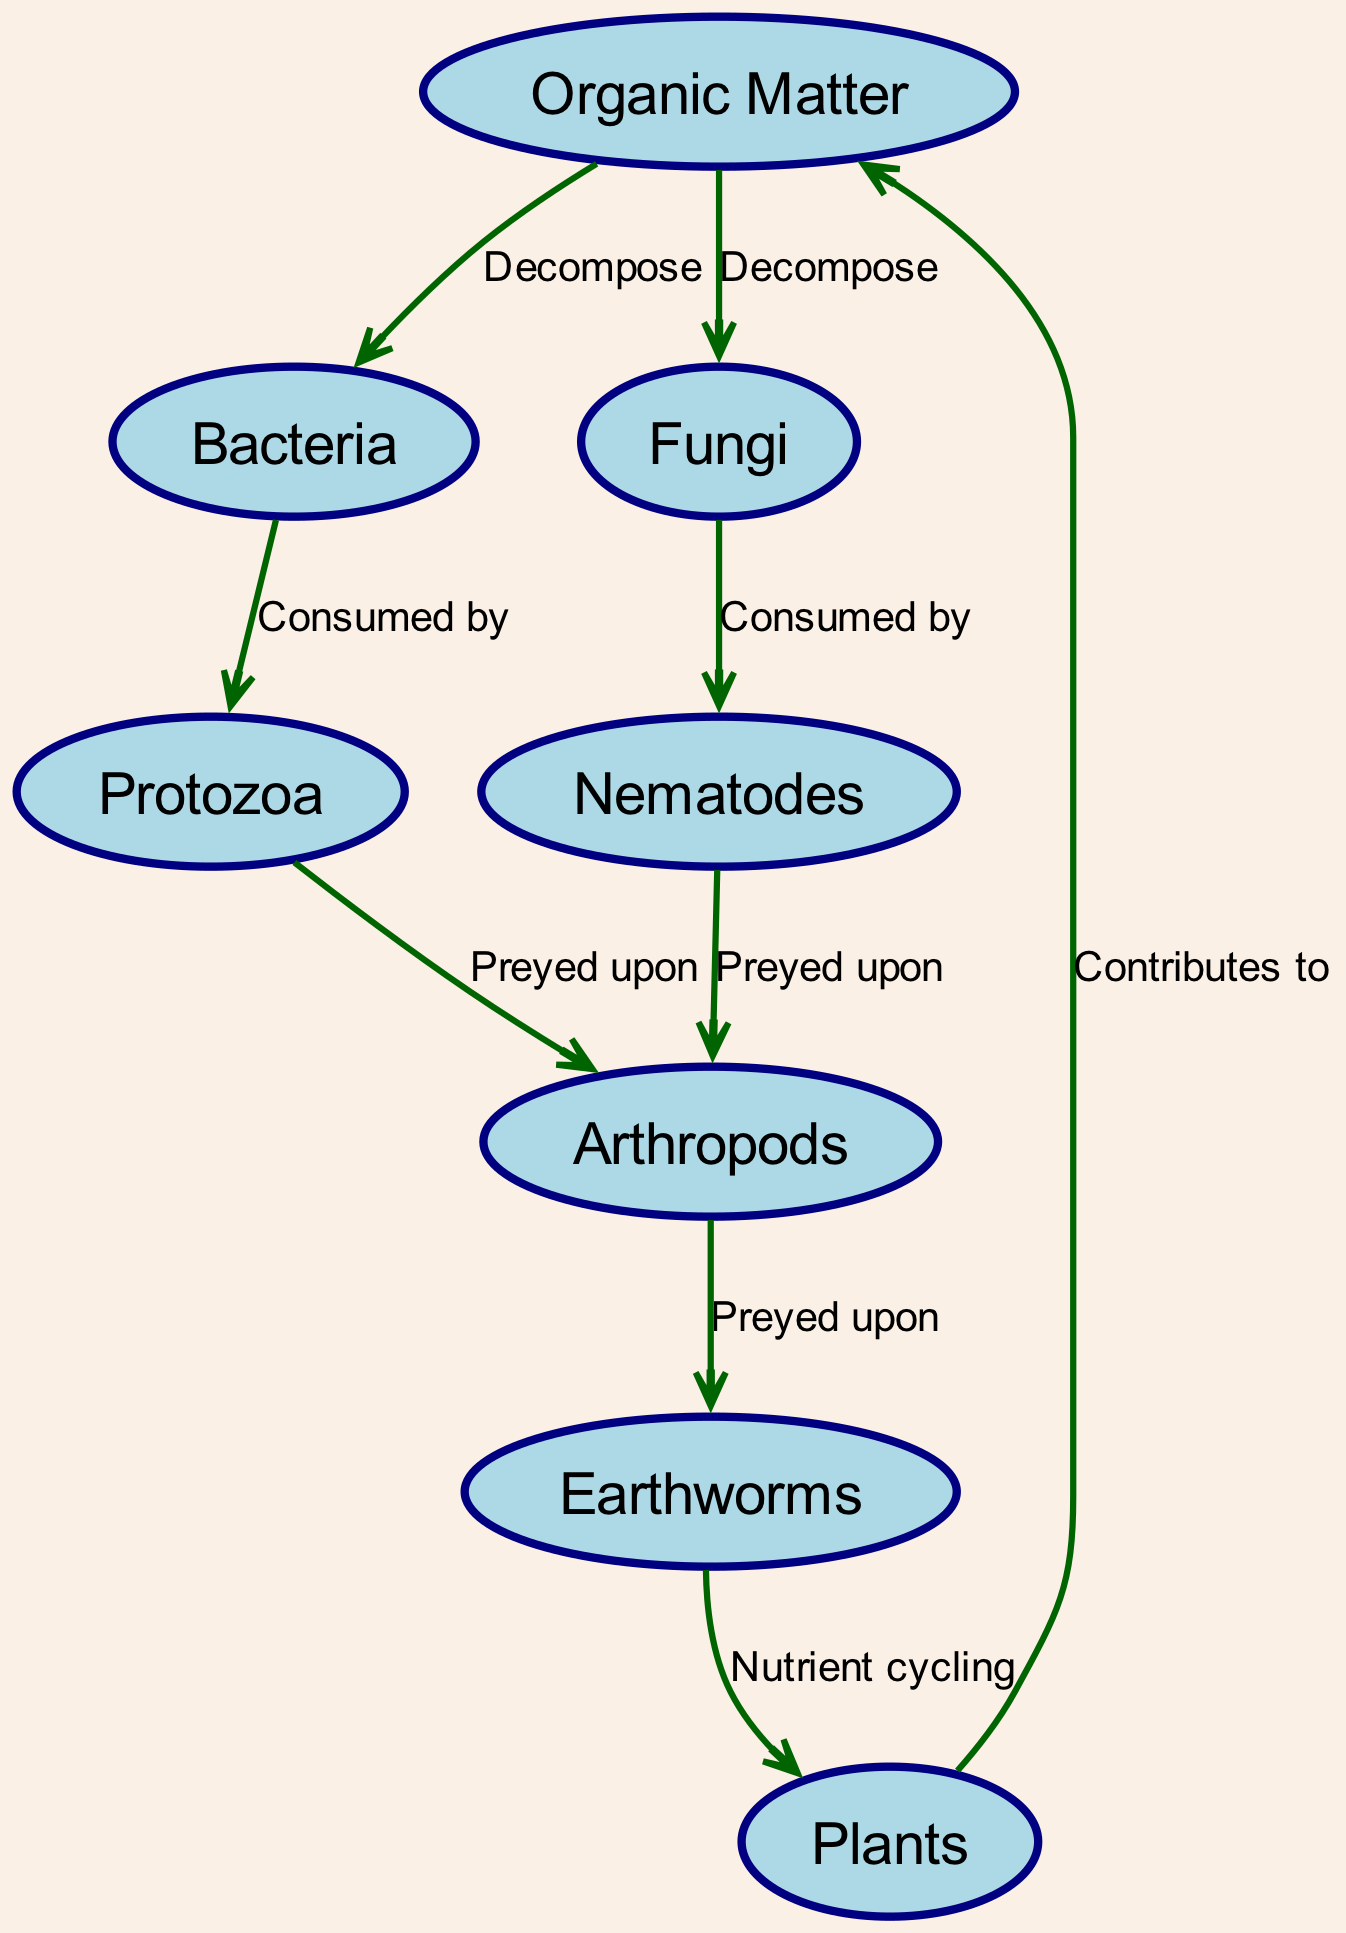What is the primary source of nutrients for bacteria? The diagram shows that bacteria decompose organic matter, indicating that organic matter serves as their primary source of nutrients.
Answer: Organic Matter How many organisms are involved in the food web? By counting the nodes in the diagram, there are eight distinct organisms, which include organic matter, bacteria, fungi, protozoa, nematodes, arthropods, earthworms, and plants.
Answer: 8 Which organism is preyed upon by both protozoa and nematodes? The diagram indicates that both protozoa and nematodes prey on arthropods, as both have directed edges leading to the arthropod node.
Answer: Arthropods What role do earthworms play in nutrient cycling? The diagram illustrates that earthworms contribute to nutrient cycling by directing a flow of nutrients to plants, indicating their role in facilitating nutrient availability in the soil ecosystem.
Answer: Nutrient cycling Which organisms directly decompose organic matter? The diagram shows direct edges indicating decomposition from organic matter to bacteria and fungi, therefore both of these organisms are responsible for this process.
Answer: Bacteria and Fungi How many predator-prey relationships are illustrated in the diagram? By counting the directed edges labeled as "Preyed upon," there are four such relationships represented in the diagram, showing how various organisms interact in a predator-prey dynamic.
Answer: 4 What sustains the flow of nutrients back to organic matter? According to the diagram, plants contribute to organic matter as they cycle nutrients back into the soil, which sustains the flow of nutrients essential for overall ecosystem health.
Answer: Contributes to Which organism is the top predator in the illustrated web? The diagram indicates that arthropods prey upon earthworms, making them the apex consumer in this soil food web, as they are not shown to be predated by any organisms in the diagram.
Answer: Arthropods 